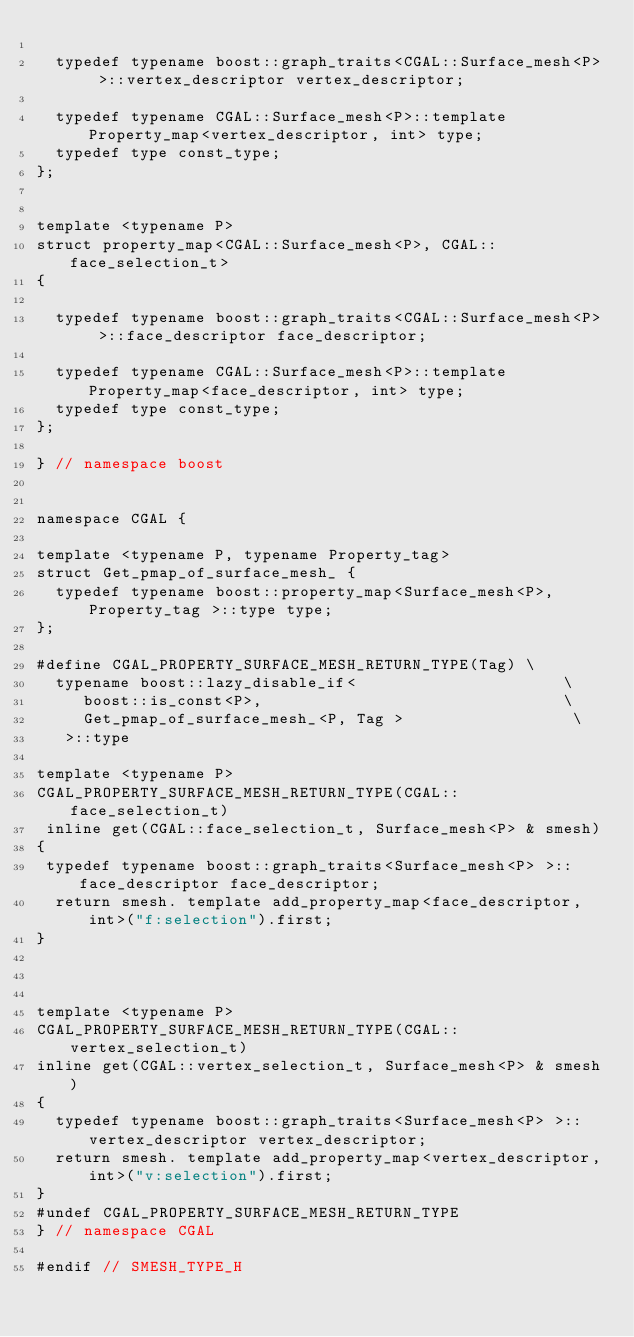<code> <loc_0><loc_0><loc_500><loc_500><_C_>
  typedef typename boost::graph_traits<CGAL::Surface_mesh<P> >::vertex_descriptor vertex_descriptor;

  typedef typename CGAL::Surface_mesh<P>::template Property_map<vertex_descriptor, int> type;
  typedef type const_type;
};


template <typename P>
struct property_map<CGAL::Surface_mesh<P>, CGAL::face_selection_t>
{

  typedef typename boost::graph_traits<CGAL::Surface_mesh<P> >::face_descriptor face_descriptor;

  typedef typename CGAL::Surface_mesh<P>::template Property_map<face_descriptor, int> type;
  typedef type const_type;
};

} // namespace boost


namespace CGAL {

template <typename P, typename Property_tag>
struct Get_pmap_of_surface_mesh_ {
  typedef typename boost::property_map<Surface_mesh<P>, Property_tag >::type type;
};

#define CGAL_PROPERTY_SURFACE_MESH_RETURN_TYPE(Tag) \
  typename boost::lazy_disable_if<                      \
     boost::is_const<P>,                                \
     Get_pmap_of_surface_mesh_<P, Tag >                  \
   >::type

template <typename P>
CGAL_PROPERTY_SURFACE_MESH_RETURN_TYPE(CGAL::face_selection_t)
 inline get(CGAL::face_selection_t, Surface_mesh<P> & smesh)
{
 typedef typename boost::graph_traits<Surface_mesh<P> >::face_descriptor face_descriptor;
  return smesh. template add_property_map<face_descriptor,int>("f:selection").first;
}



template <typename P>
CGAL_PROPERTY_SURFACE_MESH_RETURN_TYPE(CGAL::vertex_selection_t)
inline get(CGAL::vertex_selection_t, Surface_mesh<P> & smesh)
{
  typedef typename boost::graph_traits<Surface_mesh<P> >::vertex_descriptor vertex_descriptor;
  return smesh. template add_property_map<vertex_descriptor,int>("v:selection").first;
}
#undef CGAL_PROPERTY_SURFACE_MESH_RETURN_TYPE
} // namespace CGAL

#endif // SMESH_TYPE_H
</code> 